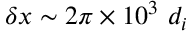Convert formula to latex. <formula><loc_0><loc_0><loc_500><loc_500>\delta x \sim 2 \pi \times 1 0 ^ { 3 } d _ { i }</formula> 